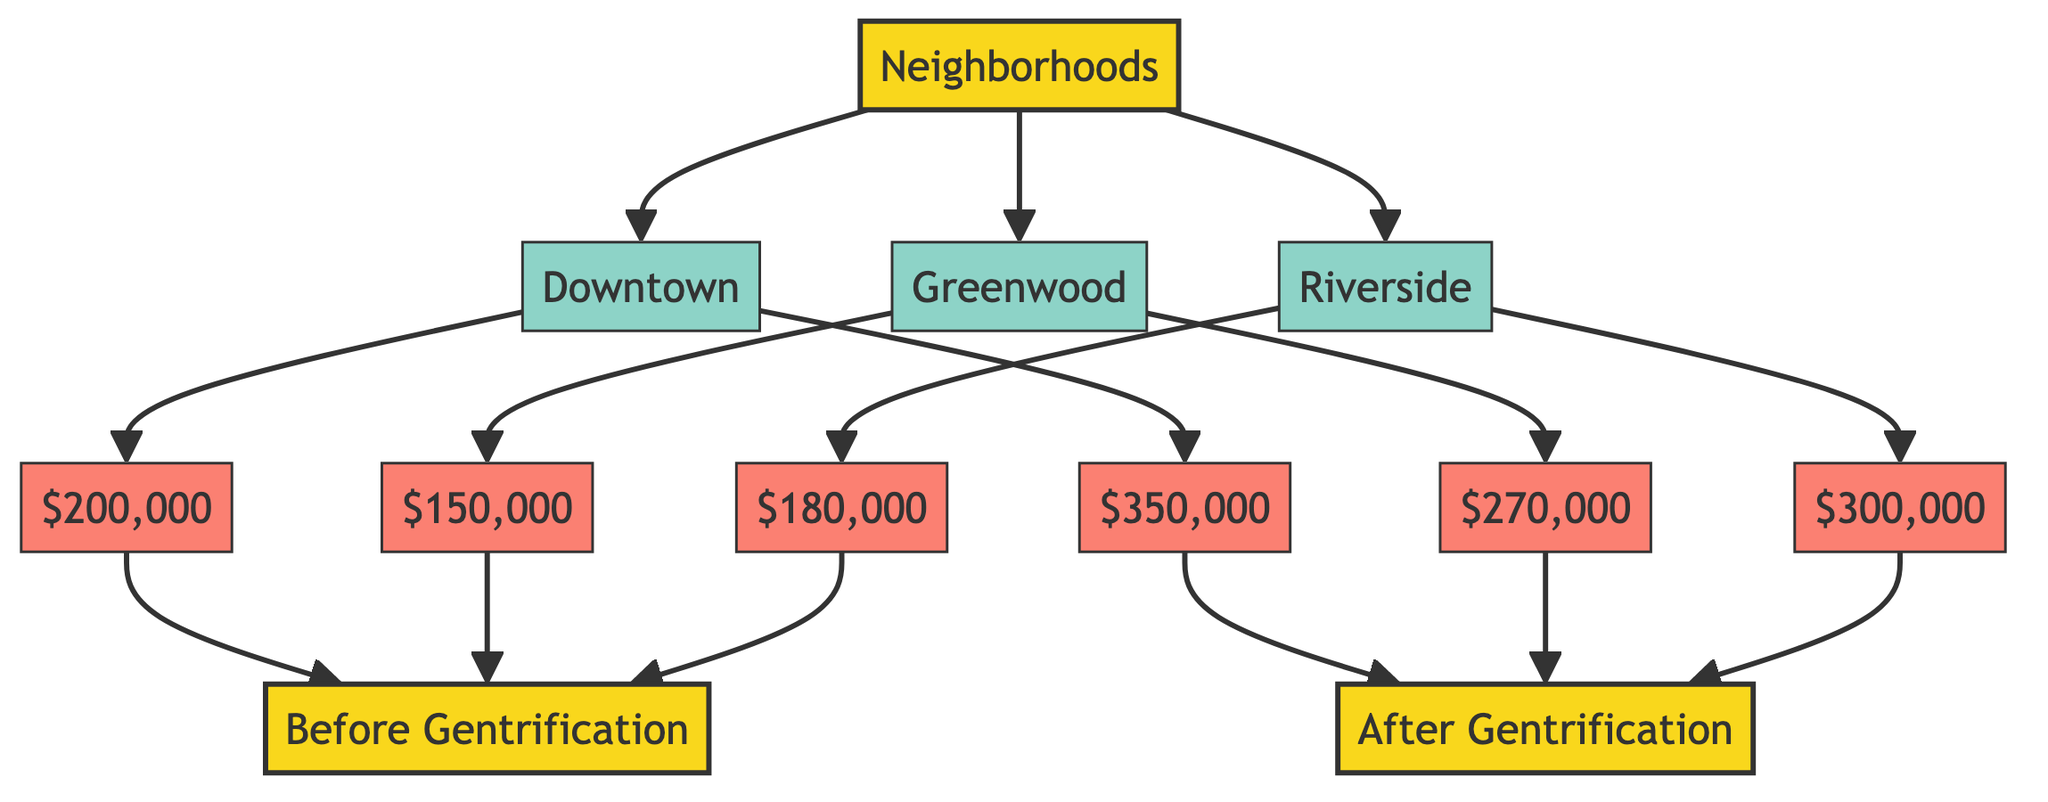What is the property value in Downtown before gentrification? In the diagram, the value for Downtown before gentrification is directly linked to the node displaying "$200,000."
Answer: $200,000 What is the property value in Riverside after gentrification? The node for Riverside after gentrification shows the value "$300,000." This value can be directly read from the diagram.
Answer: $300,000 Which neighborhood had the highest property value after gentrification? To find this, we compare the values after gentrification: Downtown has $350,000, Greenwood has $270,000, and Riverside has $300,000. Downtown has the highest value.
Answer: Downtown What is the total increase in property value for Greenwood due to gentrification? For Greenwood, the value before gentrification is $150,000 and after gentrification is $270,000. The increase can be calculated as $270,000 - $150,000 = $120,000.
Answer: $120,000 How many neighborhoods are represented in the diagram? The diagram displays three neighborhoods: Downtown, Greenwood, and Riverside. Counting these nodes gives us three neighborhoods in total.
Answer: 3 What is the difference in property value growth between Downtown and Riverside after gentrification? Downtown's value after gentrification is $350,000 and Riverside's is $300,000. The difference is calculated as $350,000 - $300,000 = $50,000.
Answer: $50,000 Which neighborhood experienced the lowest property value growth due to gentrification? By comparing the growth amounts: Downtown grew by $150,000, Greenwood by $120,000, and Riverside by $120,000. Both Greenwood and Riverside have the lowest growth of $120,000.
Answer: Greenwood and Riverside In how many instances did property values increase, according to the diagram? There are three instances where property values are shown, and they all indicate an increase: Downtown, Greenwood, and Riverside. Therefore, there are three instances of increased values.
Answer: 3 What class do both the "Before Gentrification" and "After Gentrification" belong to? The nodes "Before Gentrification" and "After Gentrification" are categorized under the class "category" in the diagram.
Answer: category 